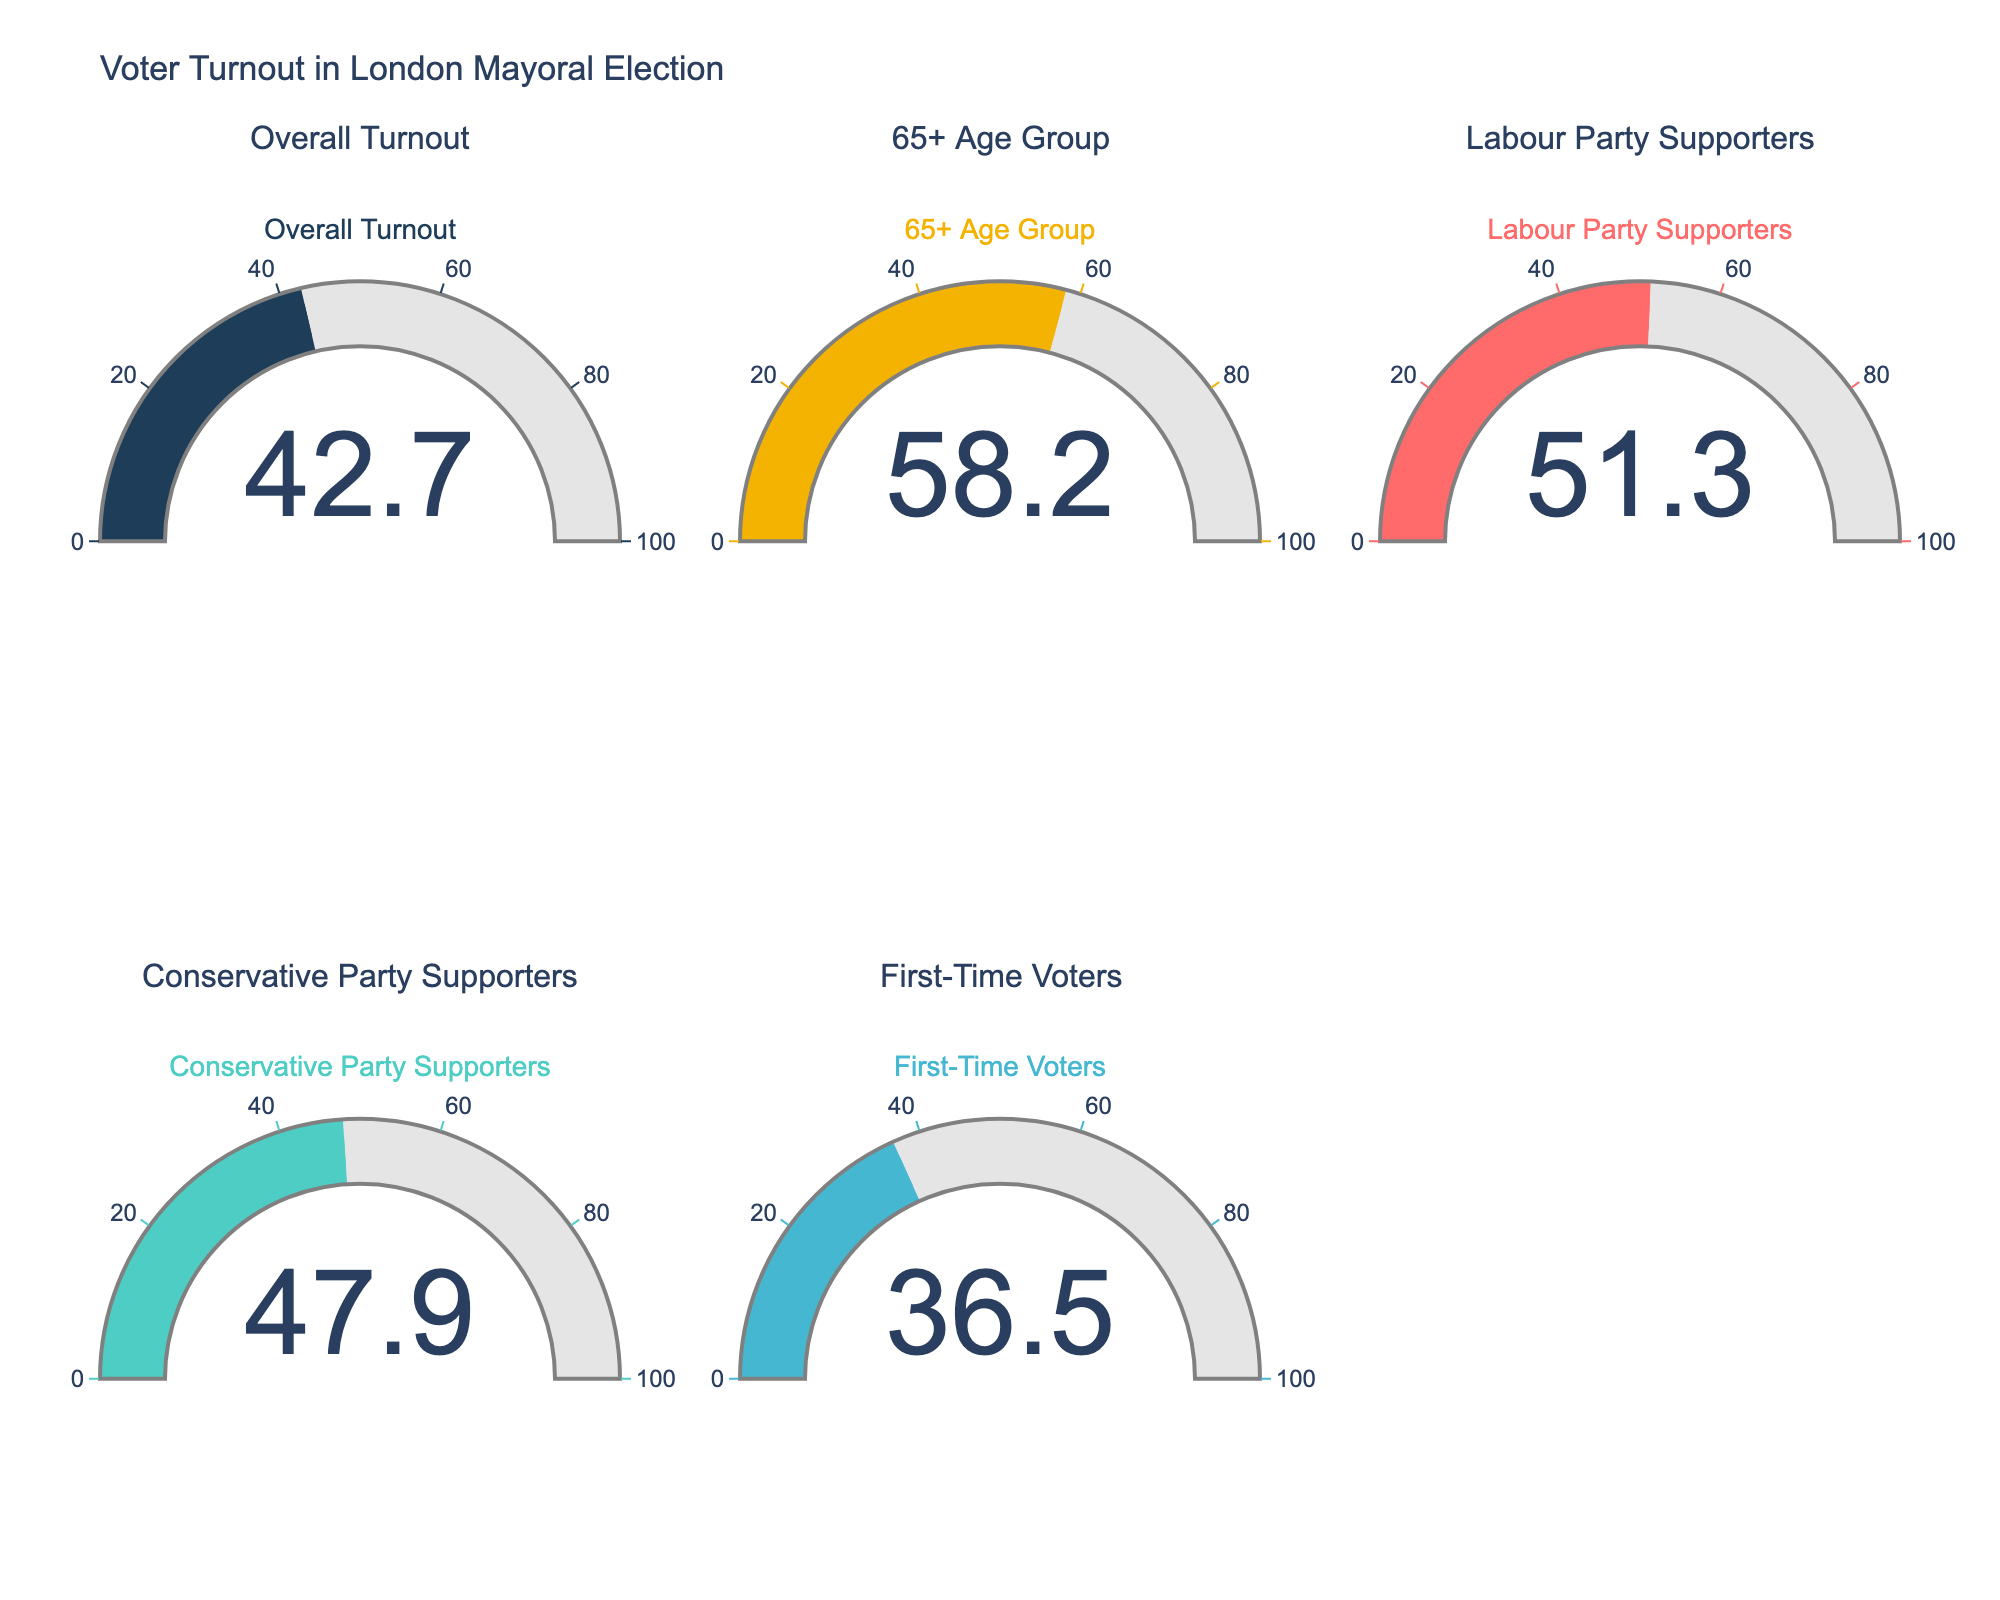What's the value displayed for the Overall Turnout? The gauge chart for Overall Turnout shows the value directly.
Answer: 42.7 Among the displayed categories, which group had the highest voter turnout? By comparing the displayed percentages for each category, the 65+ Age Group has the highest value.
Answer: 65+ Age Group What's the difference in voter turnout percentage between Labour Party Supporters and First-Time Voters? Subtract the percentage of First-Time Voters from that of Labour Party Supporters: 51.3 - 36.5 = 14.8.
Answer: 14.8 Which category had a lower turnout, Conservative Party Supporters or Overall Turnout? Compare the turnout percentages: Conservative Party Supporters (47.9) and Overall Turnout (42.7).
Answer: Overall Turnout What is the average voter turnout percentage of the given age groups (Overall Turnout, 65+)? Average of the two percentages: (42.7 + 58.2) / 2 = 50.45.
Answer: 50.45 Comparing Labour Party Supporters and Conservative Party Supporters, which had a higher voter turnout and by how much? Labour Party Supporters had a higher turnout. Subtract Conservative Party Supporters' percentage from Labour Party Supporters': 51.3 - 47.9 = 3.4.
Answer: Labour Party Supporters by 3.4 Determine the voter turnout range within the displayed categories. Identify the lowest (First-Time Voters at 36.5) and highest (65+ Age Group at 58.2) percentages. The range is 58.2 - 36.5 = 21.7.
Answer: 21.7 Which categories had turnouts below 50%? Visual inspection shows Overall Turnout (42.7), Conservative Party Supporters (47.9), and First-Time Voters (36.5) are below 50%.
Answer: Overall Turnout, Conservative Party Supporters, First-Time Voters What percentage represents the difference between the highest and the lowest voter turnout? The highest turnout is 58.2 (65+ Age Group) and the lowest is 36.5 (First-Time Voters). The difference is 58.2 - 36.5 = 21.7.
Answer: 21.7 